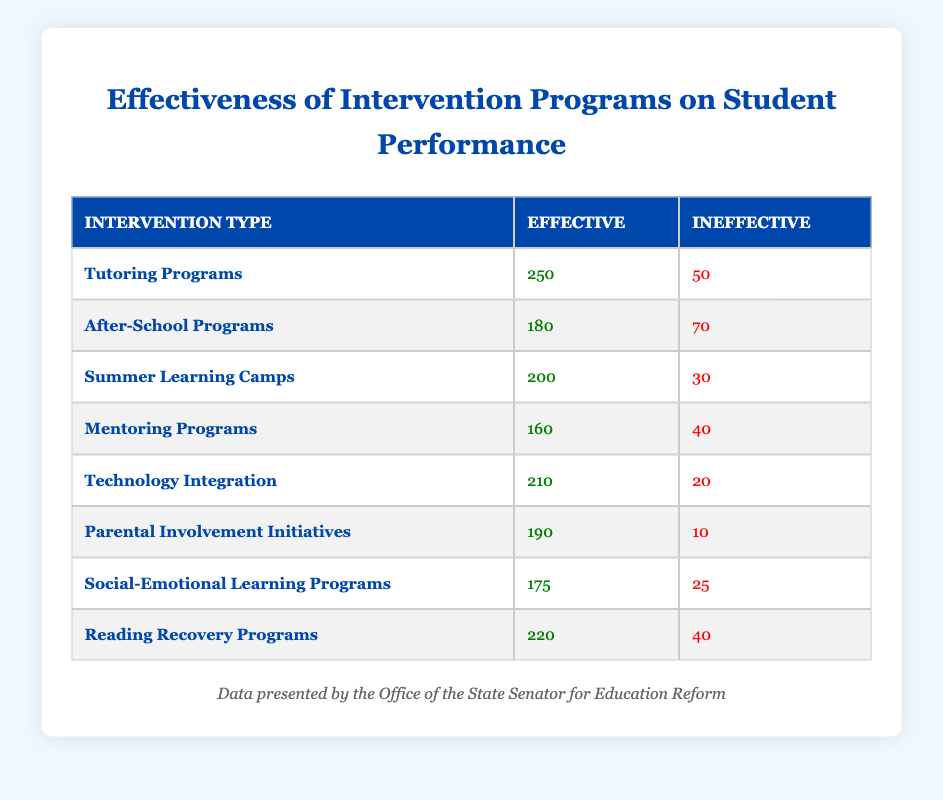What is the total number of students affected by Parental Involvement Initiatives? To find the total number of students affected by Parental Involvement Initiatives, we need to sum the numbers of Effective and Ineffective results. The values are Effective: 190 and Ineffective: 10, giving us a total of 190 + 10 = 200.
Answer: 200 Which intervention type has the highest number of effective students? By examining the Effective column, we find that Tutoring Programs have the highest number of effective students at 250.
Answer: Tutoring Programs Is the number of ineffective students in Summer Learning Camps less than that in After-School Programs? We compare the Ineffective values for both intervention types. Summer Learning Camps has 30 ineffective students whereas After-School Programs has 70. Thus, 30 is indeed less than 70.
Answer: Yes What is the total number of effective students across all intervention types? We need to sum the Effective values from all intervention types: 250 + 180 + 200 + 160 + 210 + 190 + 175 + 220 = 1395. This gives us the total number of effective students.
Answer: 1395 How many students were ineffective in Technology Integration compared to Social-Emotional Learning Programs? Technology Integration has 20 ineffective students and Social-Emotional Learning Programs has 25. We can conclude that 20 is less than 25.
Answer: Technology Integration has fewer ineffective students 